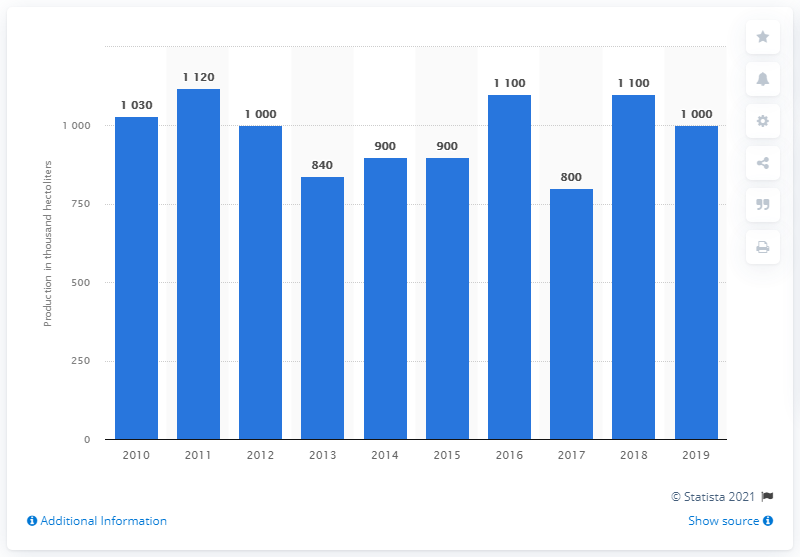Give some essential details in this illustration. The sum of the volumes below 850 is 1640. The lowest value is 800...". The volume of wine produced in Switzerland has been fluctuating since 2010. 